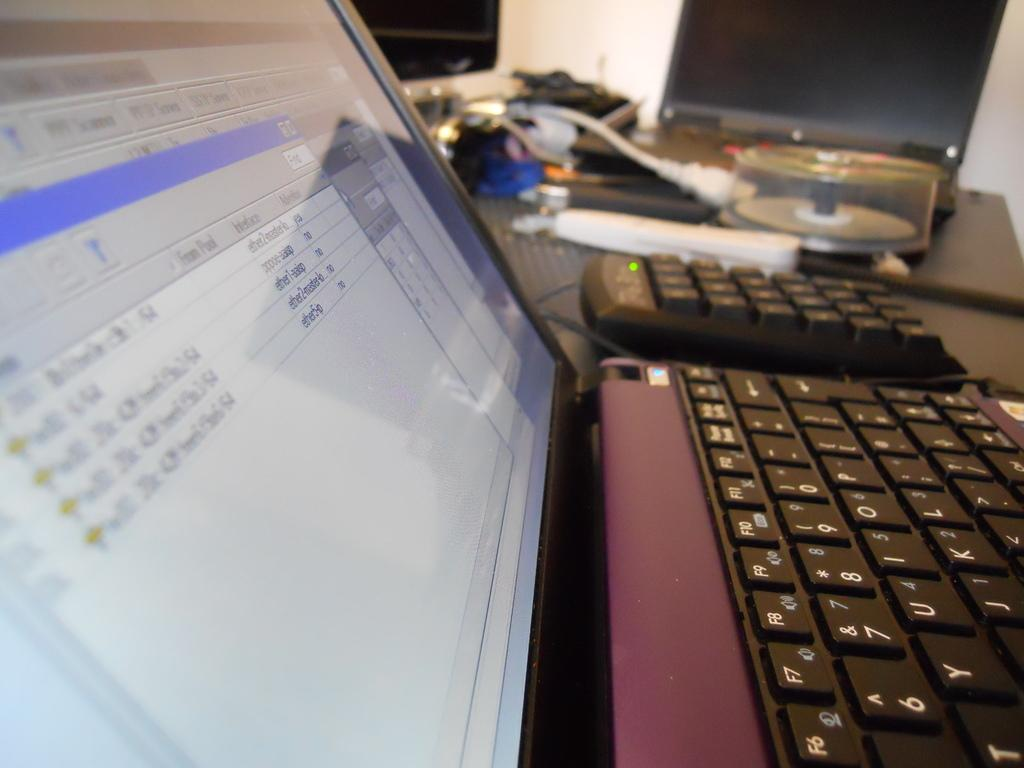What electronic device is visible in the image? There is a laptop in the image. What is a feature of the laptop? The laptop has a keyboard. What is the purpose of the CD disk box in the image? The CD disk box is likely used for storing CDs or DVDs. What connects the laptop to other devices or power sources? Cables are present in the image. What is the primary display device for the laptop? There is a monitor in the image. What other objects can be seen on the platform? There are other objects on the platform, but their specifics are not mentioned in the facts. What can be seen in the image? There is a wall in the background of the image. What type of plot is being discussed in the image? There is no plot present in the image, as it features electronic devices and objects. What is the level of interest in the image? The level of interest in the image cannot be determined, as it depends on the viewer's preferences. 